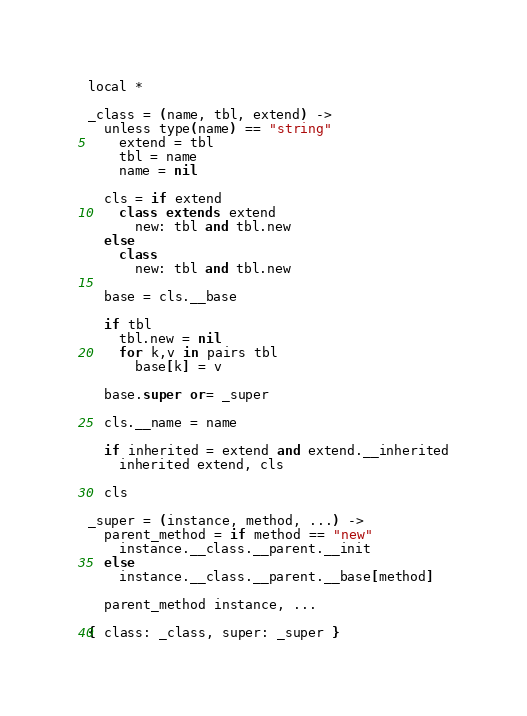<code> <loc_0><loc_0><loc_500><loc_500><_MoonScript_>
local *

_class = (name, tbl, extend) ->
  unless type(name) == "string"
    extend = tbl
    tbl = name
    name = nil

  cls = if extend
    class extends extend
      new: tbl and tbl.new
  else
    class
      new: tbl and tbl.new

  base = cls.__base

  if tbl
    tbl.new = nil
    for k,v in pairs tbl
      base[k] = v

  base.super or= _super

  cls.__name = name

  if inherited = extend and extend.__inherited
    inherited extend, cls

  cls

_super = (instance, method, ...) ->
  parent_method = if method == "new"
    instance.__class.__parent.__init
  else
    instance.__class.__parent.__base[method]

  parent_method instance, ...

{ class: _class, super: _super }
</code> 